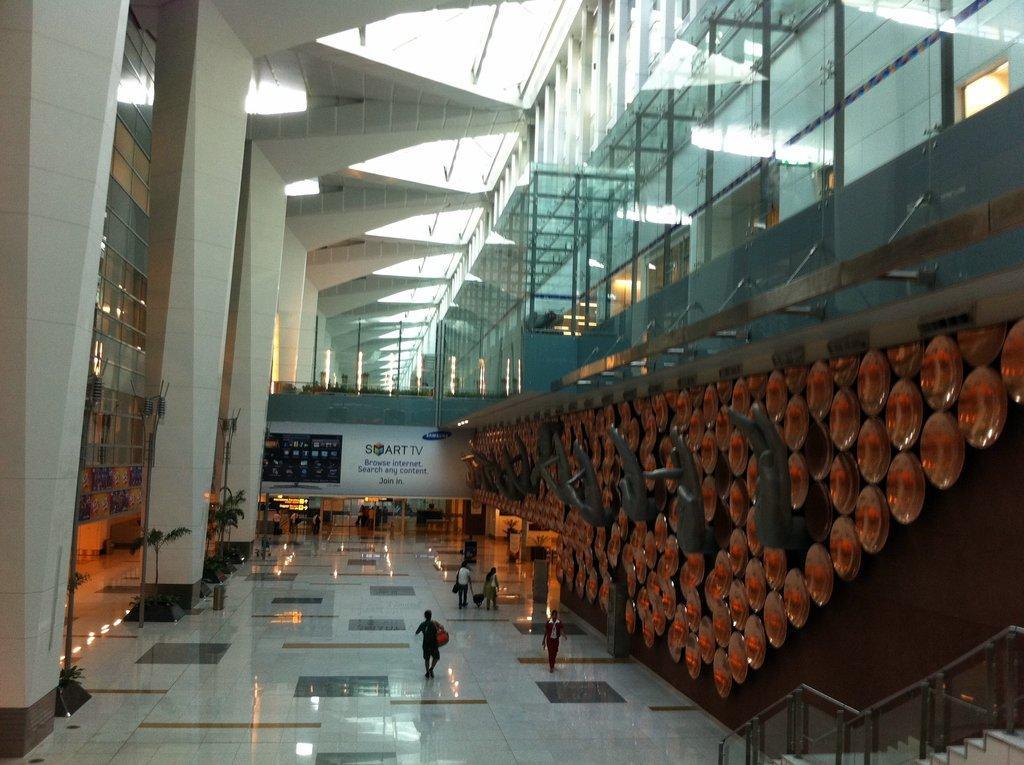Describe this image in one or two sentences. This image is taken from inside the building. In this image there are a few people standing and walking on the floor, a few are holding their luggage´s, On the right side of the image there are a few structures on the wall and there are stairs. On the left side of the image there are a few plant pots, pillars and glass wall. In the background there is a board with some images and text on it. At the top of the image there is a ceiling with glass. 